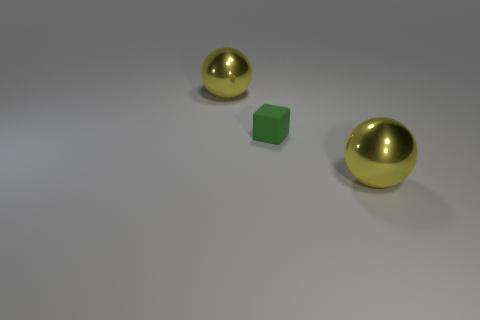Could you describe the setting or context in which these objects are placed? The objects are placed on a uniform, light-colored surface that looks smooth, giving an impression of a controlled environment like a studio or indoor space designed for showcasing or photographing objects with minimal distractions. 